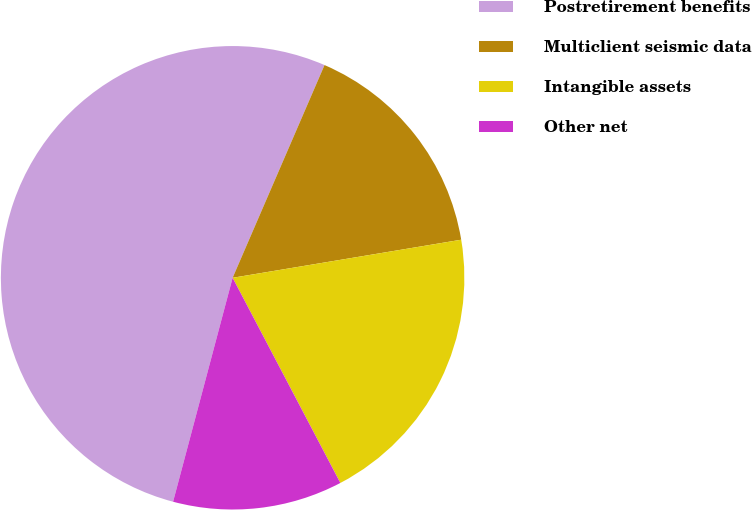Convert chart. <chart><loc_0><loc_0><loc_500><loc_500><pie_chart><fcel>Postretirement benefits<fcel>Multiclient seismic data<fcel>Intangible assets<fcel>Other net<nl><fcel>52.35%<fcel>15.88%<fcel>19.93%<fcel>11.83%<nl></chart> 